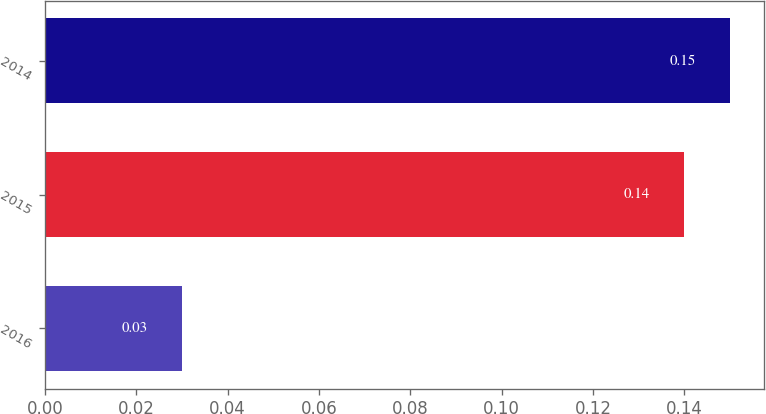Convert chart. <chart><loc_0><loc_0><loc_500><loc_500><bar_chart><fcel>2016<fcel>2015<fcel>2014<nl><fcel>0.03<fcel>0.14<fcel>0.15<nl></chart> 